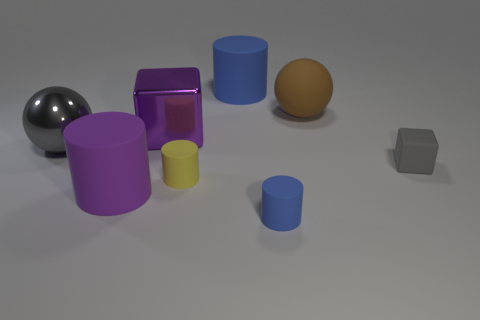How many other things are the same shape as the yellow object?
Ensure brevity in your answer.  3. The big brown thing that is made of the same material as the big blue object is what shape?
Your answer should be very brief. Sphere. What material is the tiny blue cylinder to the left of the big sphere on the right side of the big object that is behind the rubber ball?
Your answer should be compact. Rubber. There is a gray rubber object; does it have the same size as the block that is on the left side of the brown sphere?
Provide a succinct answer. No. There is a brown object that is the same shape as the big gray metallic object; what is its material?
Your answer should be compact. Rubber. What is the size of the blue object that is behind the blue cylinder in front of the blue rubber object behind the big gray sphere?
Make the answer very short. Large. Is the brown sphere the same size as the purple matte thing?
Provide a short and direct response. Yes. What material is the tiny cylinder that is left of the big rubber cylinder to the right of the purple cube made of?
Make the answer very short. Rubber. Is the shape of the matte thing that is on the right side of the brown matte ball the same as the large matte object that is in front of the gray sphere?
Ensure brevity in your answer.  No. Is the number of brown matte objects in front of the small gray block the same as the number of red objects?
Make the answer very short. Yes. 